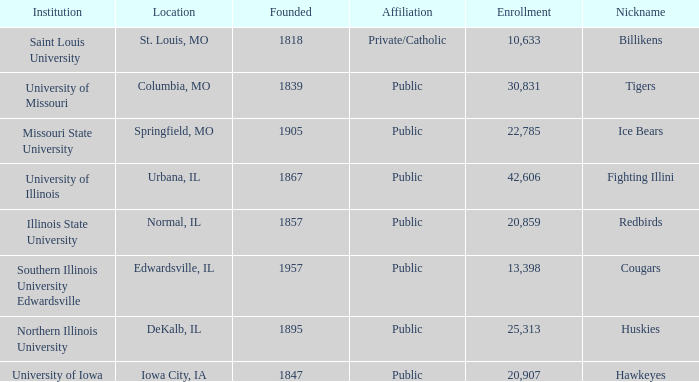Which institution is private/catholic? Saint Louis University. 